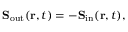Convert formula to latex. <formula><loc_0><loc_0><loc_500><loc_500>S _ { o u t } ( r , t ) = - S _ { i n } ( r , t ) ,</formula> 